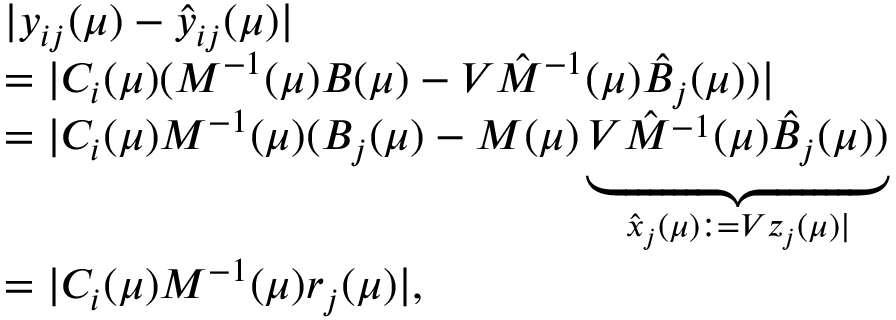Convert formula to latex. <formula><loc_0><loc_0><loc_500><loc_500>\begin{array} { l } { | y _ { i j } ( \mu ) - \hat { y } _ { i j } ( \mu ) | } \\ { = | C _ { i } ( \mu ) ( M ^ { - 1 } ( \mu ) B ( \mu ) - V \hat { M } ^ { - 1 } ( \mu ) \hat { B } _ { j } ( \mu ) ) | } \\ { = | C _ { i } ( \mu ) M ^ { - 1 } ( \mu ) ( B _ { j } ( \mu ) - M ( \mu ) \underbrace { V \hat { M } ^ { - 1 } ( \mu ) \hat { B } _ { j } ( \mu ) ) } _ { \hat { x } _ { j } ( \mu ) \colon = V z _ { j } ( \mu ) | } } \\ { = | C _ { i } ( \mu ) M ^ { - 1 } ( \mu ) r _ { j } ( \mu ) | , } \end{array}</formula> 